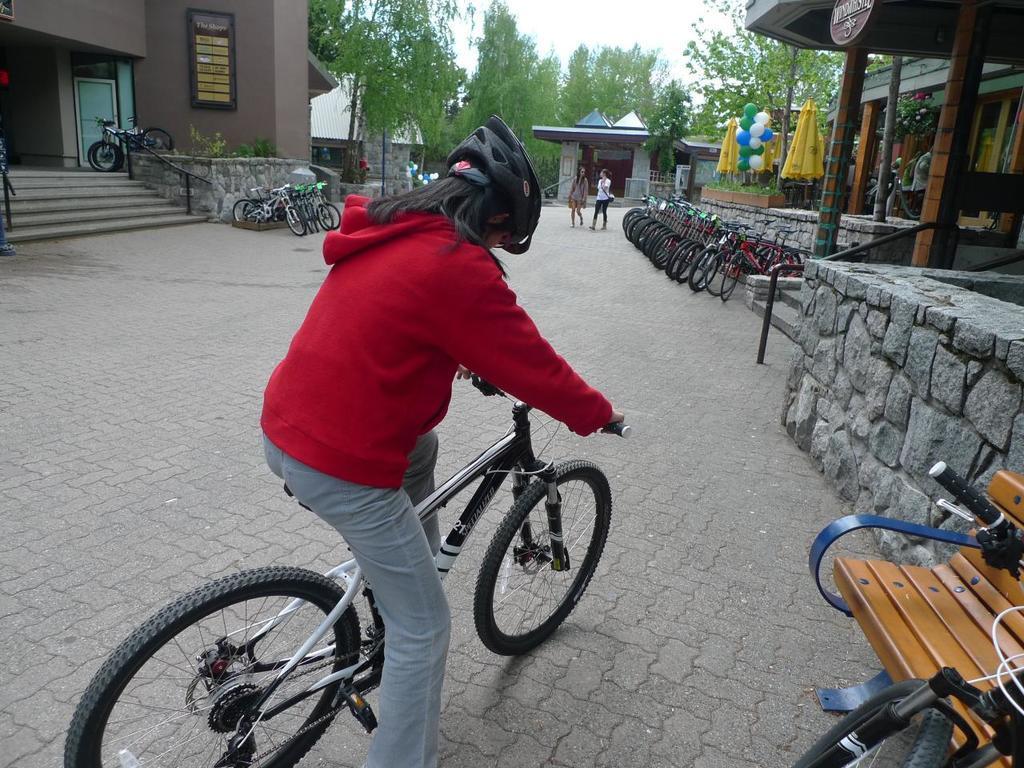Could you give a brief overview of what you see in this image? In this picture there is a girl in the center of the image on a bicycle and there is a bench and a bicycle in the bottom right side of the image, there are trees, bicycles, balloons, people, and houses in the background area of the image, it seems to be there is a stall in the top right side of the image. 